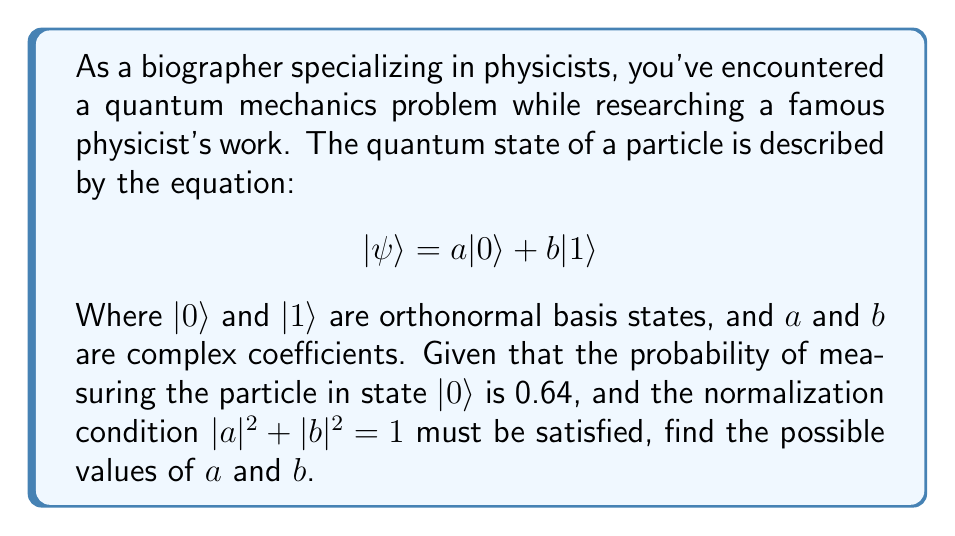Solve this math problem. Let's approach this step-by-step:

1) The probability of measuring the particle in state $|0\rangle$ is given by $|a|^2 = 0.64$

2) We know that $a$ is a complex number, so we can write it as $a = \pm \sqrt{0.64} = \pm 0.8$

3) From the normalization condition, we have:
   $$|a|^2 + |b|^2 = 1$$

4) Substituting the known value of $|a|^2$:
   $$0.64 + |b|^2 = 1$$

5) Solving for $|b|^2$:
   $$|b|^2 = 1 - 0.64 = 0.36$$

6) Therefore, $b = \pm \sqrt{0.36} = \pm 0.6$

7) Combining the results, we have four possible combinations:
   $a = 0.8, b = 0.6$
   $a = 0.8, b = -0.6$
   $a = -0.8, b = 0.6$
   $a = -0.8, b = -0.6$

Note that these are the magnitudes of $a$ and $b$. In quantum mechanics, these coefficients can also have complex phases, which are not determined by the given information.
Answer: The possible values for $a$ and $b$ are:
$a = \pm 0.8, b = \pm 0.6$ 